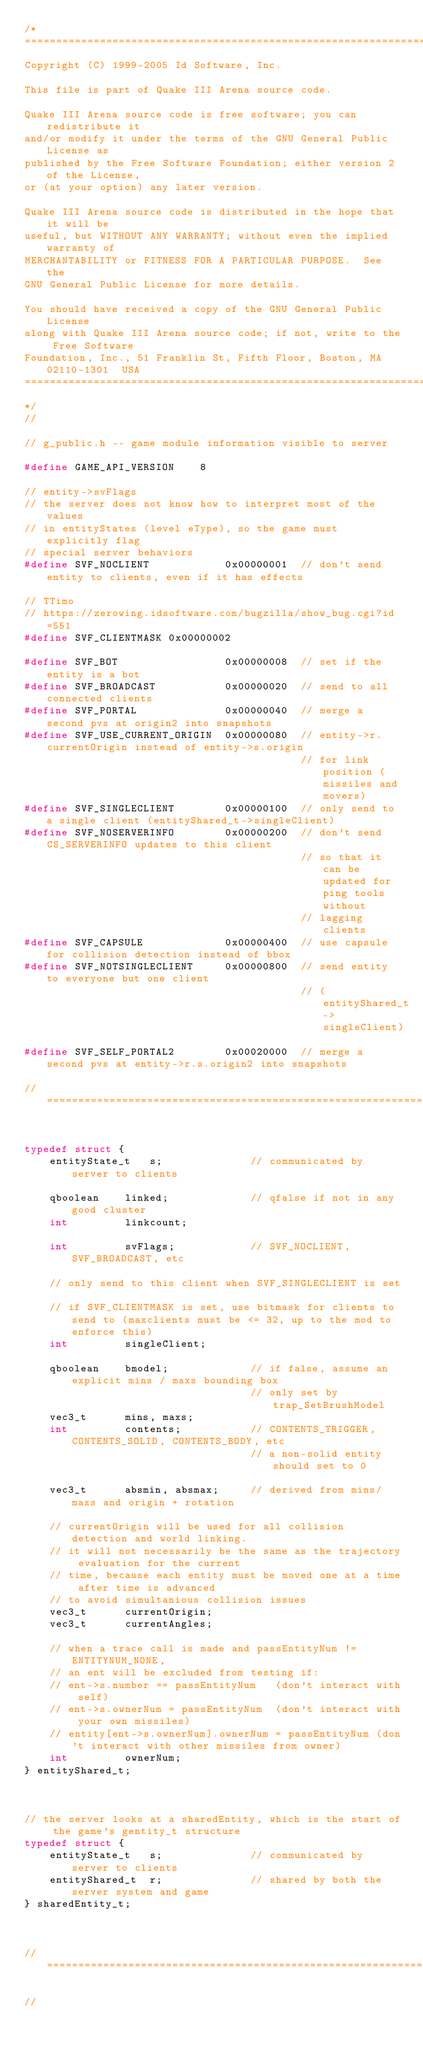<code> <loc_0><loc_0><loc_500><loc_500><_C_>/*
===========================================================================
Copyright (C) 1999-2005 Id Software, Inc.

This file is part of Quake III Arena source code.

Quake III Arena source code is free software; you can redistribute it
and/or modify it under the terms of the GNU General Public License as
published by the Free Software Foundation; either version 2 of the License,
or (at your option) any later version.

Quake III Arena source code is distributed in the hope that it will be
useful, but WITHOUT ANY WARRANTY; without even the implied warranty of
MERCHANTABILITY or FITNESS FOR A PARTICULAR PURPOSE.  See the
GNU General Public License for more details.

You should have received a copy of the GNU General Public License
along with Quake III Arena source code; if not, write to the Free Software
Foundation, Inc., 51 Franklin St, Fifth Floor, Boston, MA  02110-1301  USA
===========================================================================
*/
//

// g_public.h -- game module information visible to server

#define	GAME_API_VERSION	8

// entity->svFlags
// the server does not know how to interpret most of the values
// in entityStates (level eType), so the game must explicitly flag
// special server behaviors
#define	SVF_NOCLIENT			0x00000001	// don't send entity to clients, even if it has effects

// TTimo
// https://zerowing.idsoftware.com/bugzilla/show_bug.cgi?id=551
#define SVF_CLIENTMASK 0x00000002

#define SVF_BOT					0x00000008	// set if the entity is a bot
#define	SVF_BROADCAST			0x00000020	// send to all connected clients
#define	SVF_PORTAL				0x00000040	// merge a second pvs at origin2 into snapshots
#define	SVF_USE_CURRENT_ORIGIN	0x00000080	// entity->r.currentOrigin instead of entity->s.origin
											// for link position (missiles and movers)
#define SVF_SINGLECLIENT		0x00000100	// only send to a single client (entityShared_t->singleClient)
#define SVF_NOSERVERINFO		0x00000200	// don't send CS_SERVERINFO updates to this client
											// so that it can be updated for ping tools without
											// lagging clients
#define SVF_CAPSULE				0x00000400	// use capsule for collision detection instead of bbox
#define SVF_NOTSINGLECLIENT		0x00000800	// send entity to everyone but one client
											// (entityShared_t->singleClient)

#define SVF_SELF_PORTAL2		0x00020000  // merge a second pvs at entity->r.s.origin2 into snapshots

//===============================================================


typedef struct {
	entityState_t	s;				// communicated by server to clients

	qboolean	linked;				// qfalse if not in any good cluster
	int			linkcount;

	int			svFlags;			// SVF_NOCLIENT, SVF_BROADCAST, etc

	// only send to this client when SVF_SINGLECLIENT is set	
	// if SVF_CLIENTMASK is set, use bitmask for clients to send to (maxclients must be <= 32, up to the mod to enforce this)
	int			singleClient;		

	qboolean	bmodel;				// if false, assume an explicit mins / maxs bounding box
									// only set by trap_SetBrushModel
	vec3_t		mins, maxs;
	int			contents;			// CONTENTS_TRIGGER, CONTENTS_SOLID, CONTENTS_BODY, etc
									// a non-solid entity should set to 0

	vec3_t		absmin, absmax;		// derived from mins/maxs and origin + rotation

	// currentOrigin will be used for all collision detection and world linking.
	// it will not necessarily be the same as the trajectory evaluation for the current
	// time, because each entity must be moved one at a time after time is advanced
	// to avoid simultanious collision issues
	vec3_t		currentOrigin;
	vec3_t		currentAngles;

	// when a trace call is made and passEntityNum != ENTITYNUM_NONE,
	// an ent will be excluded from testing if:
	// ent->s.number == passEntityNum	(don't interact with self)
	// ent->s.ownerNum = passEntityNum	(don't interact with your own missiles)
	// entity[ent->s.ownerNum].ownerNum = passEntityNum	(don't interact with other missiles from owner)
	int			ownerNum;
} entityShared_t;



// the server looks at a sharedEntity, which is the start of the game's gentity_t structure
typedef struct {
	entityState_t	s;				// communicated by server to clients
	entityShared_t	r;				// shared by both the server system and game
} sharedEntity_t;



//===============================================================

//</code> 